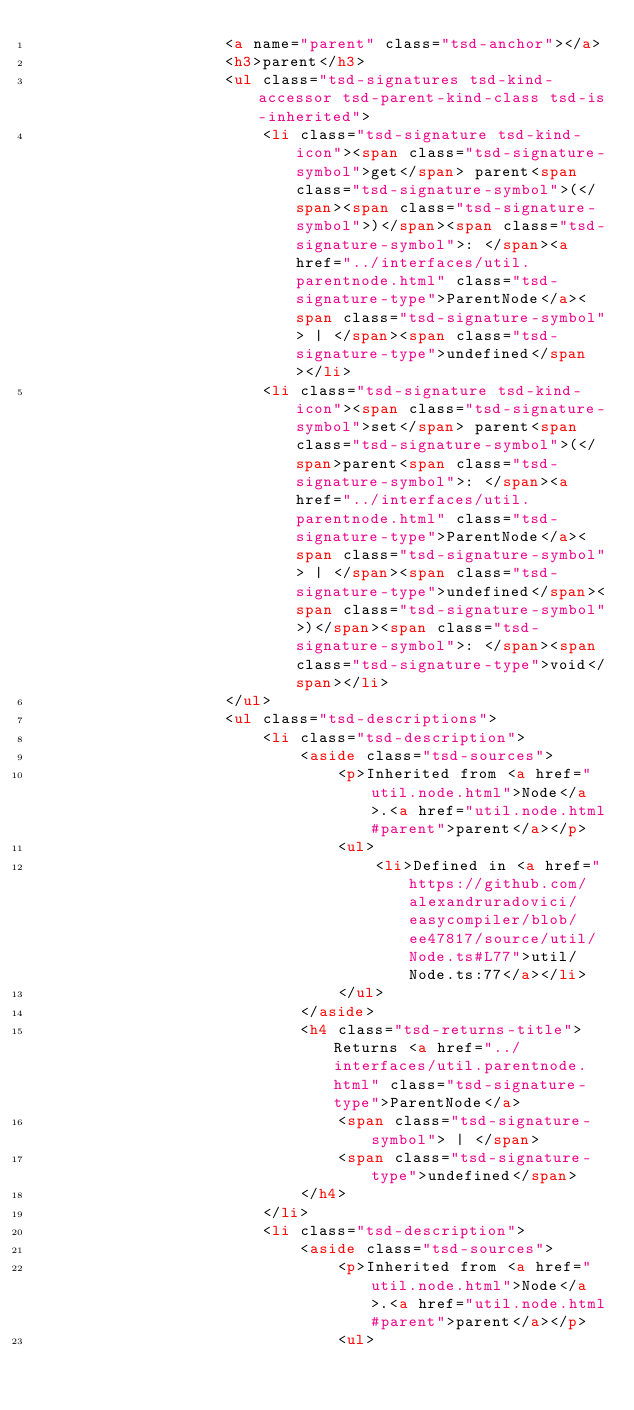Convert code to text. <code><loc_0><loc_0><loc_500><loc_500><_HTML_>					<a name="parent" class="tsd-anchor"></a>
					<h3>parent</h3>
					<ul class="tsd-signatures tsd-kind-accessor tsd-parent-kind-class tsd-is-inherited">
						<li class="tsd-signature tsd-kind-icon"><span class="tsd-signature-symbol">get</span> parent<span class="tsd-signature-symbol">(</span><span class="tsd-signature-symbol">)</span><span class="tsd-signature-symbol">: </span><a href="../interfaces/util.parentnode.html" class="tsd-signature-type">ParentNode</a><span class="tsd-signature-symbol"> | </span><span class="tsd-signature-type">undefined</span></li>
						<li class="tsd-signature tsd-kind-icon"><span class="tsd-signature-symbol">set</span> parent<span class="tsd-signature-symbol">(</span>parent<span class="tsd-signature-symbol">: </span><a href="../interfaces/util.parentnode.html" class="tsd-signature-type">ParentNode</a><span class="tsd-signature-symbol"> | </span><span class="tsd-signature-type">undefined</span><span class="tsd-signature-symbol">)</span><span class="tsd-signature-symbol">: </span><span class="tsd-signature-type">void</span></li>
					</ul>
					<ul class="tsd-descriptions">
						<li class="tsd-description">
							<aside class="tsd-sources">
								<p>Inherited from <a href="util.node.html">Node</a>.<a href="util.node.html#parent">parent</a></p>
								<ul>
									<li>Defined in <a href="https://github.com/alexandruradovici/easycompiler/blob/ee47817/source/util/Node.ts#L77">util/Node.ts:77</a></li>
								</ul>
							</aside>
							<h4 class="tsd-returns-title">Returns <a href="../interfaces/util.parentnode.html" class="tsd-signature-type">ParentNode</a>
								<span class="tsd-signature-symbol"> | </span>
								<span class="tsd-signature-type">undefined</span>
							</h4>
						</li>
						<li class="tsd-description">
							<aside class="tsd-sources">
								<p>Inherited from <a href="util.node.html">Node</a>.<a href="util.node.html#parent">parent</a></p>
								<ul></code> 